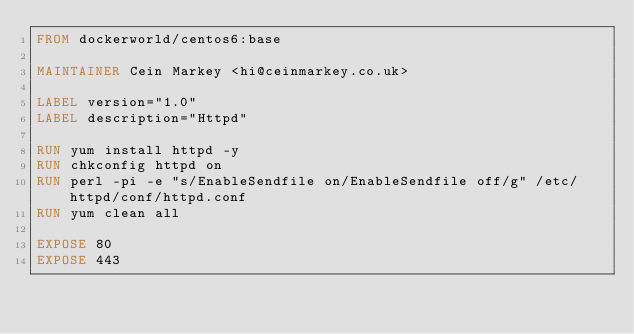<code> <loc_0><loc_0><loc_500><loc_500><_Dockerfile_>FROM dockerworld/centos6:base

MAINTAINER Cein Markey <hi@ceinmarkey.co.uk>

LABEL version="1.0"
LABEL description="Httpd"

RUN yum install httpd -y
RUN chkconfig httpd on
RUN perl -pi -e "s/EnableSendfile on/EnableSendfile off/g" /etc/httpd/conf/httpd.conf
RUN yum clean all

EXPOSE 80
EXPOSE 443</code> 